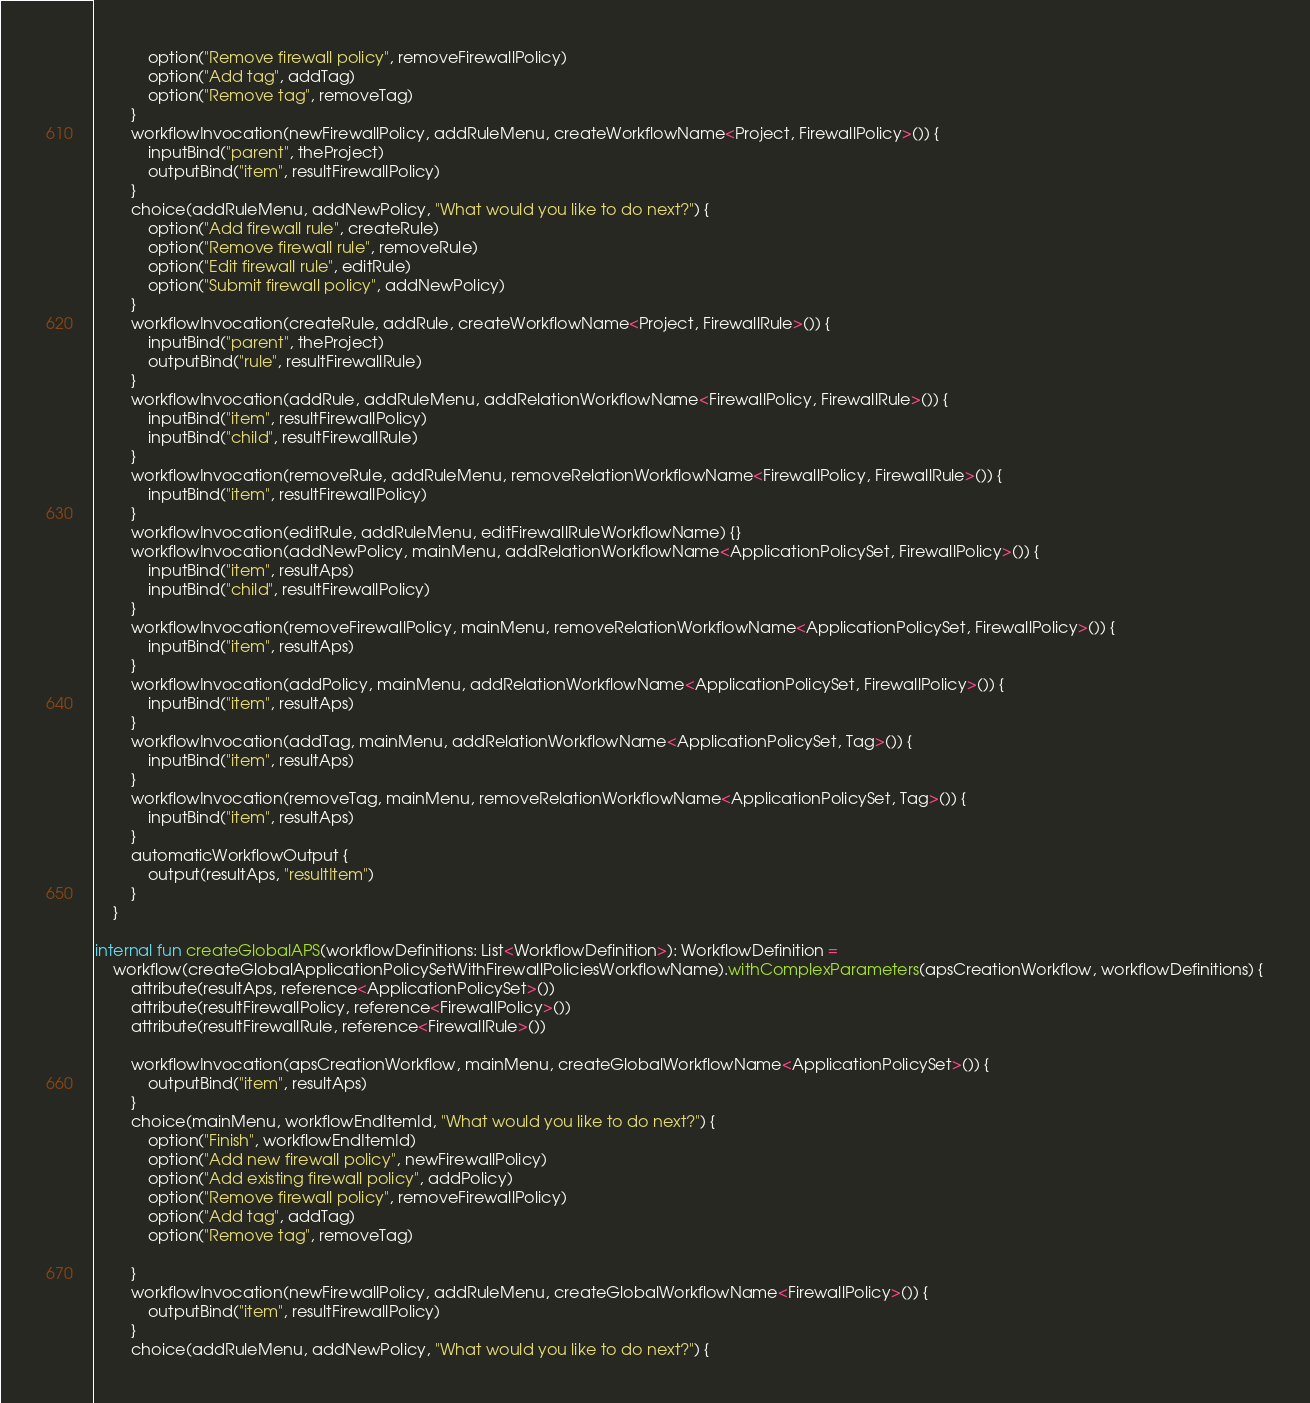Convert code to text. <code><loc_0><loc_0><loc_500><loc_500><_Kotlin_>            option("Remove firewall policy", removeFirewallPolicy)
            option("Add tag", addTag)
            option("Remove tag", removeTag)
        }
        workflowInvocation(newFirewallPolicy, addRuleMenu, createWorkflowName<Project, FirewallPolicy>()) {
            inputBind("parent", theProject)
            outputBind("item", resultFirewallPolicy)
        }
        choice(addRuleMenu, addNewPolicy, "What would you like to do next?") {
            option("Add firewall rule", createRule)
            option("Remove firewall rule", removeRule)
            option("Edit firewall rule", editRule)
            option("Submit firewall policy", addNewPolicy)
        }
        workflowInvocation(createRule, addRule, createWorkflowName<Project, FirewallRule>()) {
            inputBind("parent", theProject)
            outputBind("rule", resultFirewallRule)
        }
        workflowInvocation(addRule, addRuleMenu, addRelationWorkflowName<FirewallPolicy, FirewallRule>()) {
            inputBind("item", resultFirewallPolicy)
            inputBind("child", resultFirewallRule)
        }
        workflowInvocation(removeRule, addRuleMenu, removeRelationWorkflowName<FirewallPolicy, FirewallRule>()) {
            inputBind("item", resultFirewallPolicy)
        }
        workflowInvocation(editRule, addRuleMenu, editFirewallRuleWorkflowName) {}
        workflowInvocation(addNewPolicy, mainMenu, addRelationWorkflowName<ApplicationPolicySet, FirewallPolicy>()) {
            inputBind("item", resultAps)
            inputBind("child", resultFirewallPolicy)
        }
        workflowInvocation(removeFirewallPolicy, mainMenu, removeRelationWorkflowName<ApplicationPolicySet, FirewallPolicy>()) {
            inputBind("item", resultAps)
        }
        workflowInvocation(addPolicy, mainMenu, addRelationWorkflowName<ApplicationPolicySet, FirewallPolicy>()) {
            inputBind("item", resultAps)
        }
        workflowInvocation(addTag, mainMenu, addRelationWorkflowName<ApplicationPolicySet, Tag>()) {
            inputBind("item", resultAps)
        }
        workflowInvocation(removeTag, mainMenu, removeRelationWorkflowName<ApplicationPolicySet, Tag>()) {
            inputBind("item", resultAps)
        }
        automaticWorkflowOutput {
            output(resultAps, "resultItem")
        }
    }

internal fun createGlobalAPS(workflowDefinitions: List<WorkflowDefinition>): WorkflowDefinition =
    workflow(createGlobalApplicationPolicySetWithFirewallPoliciesWorkflowName).withComplexParameters(apsCreationWorkflow, workflowDefinitions) {
        attribute(resultAps, reference<ApplicationPolicySet>())
        attribute(resultFirewallPolicy, reference<FirewallPolicy>())
        attribute(resultFirewallRule, reference<FirewallRule>())

        workflowInvocation(apsCreationWorkflow, mainMenu, createGlobalWorkflowName<ApplicationPolicySet>()) {
            outputBind("item", resultAps)
        }
        choice(mainMenu, workflowEndItemId, "What would you like to do next?") {
            option("Finish", workflowEndItemId)
            option("Add new firewall policy", newFirewallPolicy)
            option("Add existing firewall policy", addPolicy)
            option("Remove firewall policy", removeFirewallPolicy)
            option("Add tag", addTag)
            option("Remove tag", removeTag)

        }
        workflowInvocation(newFirewallPolicy, addRuleMenu, createGlobalWorkflowName<FirewallPolicy>()) {
            outputBind("item", resultFirewallPolicy)
        }
        choice(addRuleMenu, addNewPolicy, "What would you like to do next?") {</code> 